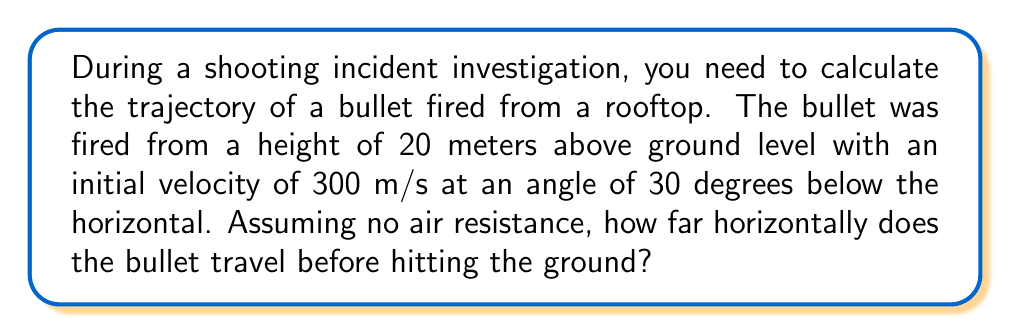Provide a solution to this math problem. To solve this problem, we'll use the equations of motion for projectile motion. Let's break it down step by step:

1. Identify the known variables:
   - Initial height, $h_0 = 20$ m
   - Initial velocity, $v_0 = 300$ m/s
   - Angle below horizontal, $\theta = 30°$
   - Acceleration due to gravity, $g = 9.8$ m/s²

2. Calculate the initial velocity components:
   $v_{0x} = v_0 \cos(90°-\theta) = 300 \cos(60°) = 150$ m/s
   $v_{0y} = -v_0 \sin(90°-\theta) = -300 \sin(60°) = -259.8$ m/s

3. Use the equation for the time it takes the bullet to reach the ground:
   $$h = h_0 + v_{0y}t + \frac{1}{2}gt^2$$
   $$0 = 20 + (-259.8)t + \frac{1}{2}(9.8)t^2$$

4. Solve the quadratic equation:
   $$4.9t^2 - 259.8t + 20 = 0$$
   Using the quadratic formula: $t = \frac{259.8 \pm \sqrt{259.8^2 - 4(4.9)(20)}}{2(4.9)}$
   $t \approx 5.44$ seconds

5. Calculate the horizontal distance traveled:
   $$x = v_{0x}t = 150 \cdot 5.44 \approx 816$ meters
Answer: 816 meters 